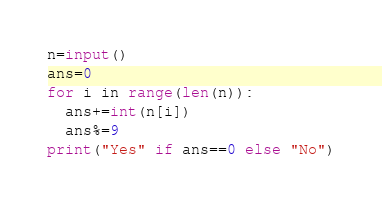<code> <loc_0><loc_0><loc_500><loc_500><_Python_>n=input()
ans=0
for i in range(len(n)):
  ans+=int(n[i])
  ans%=9
print("Yes" if ans==0 else "No")</code> 